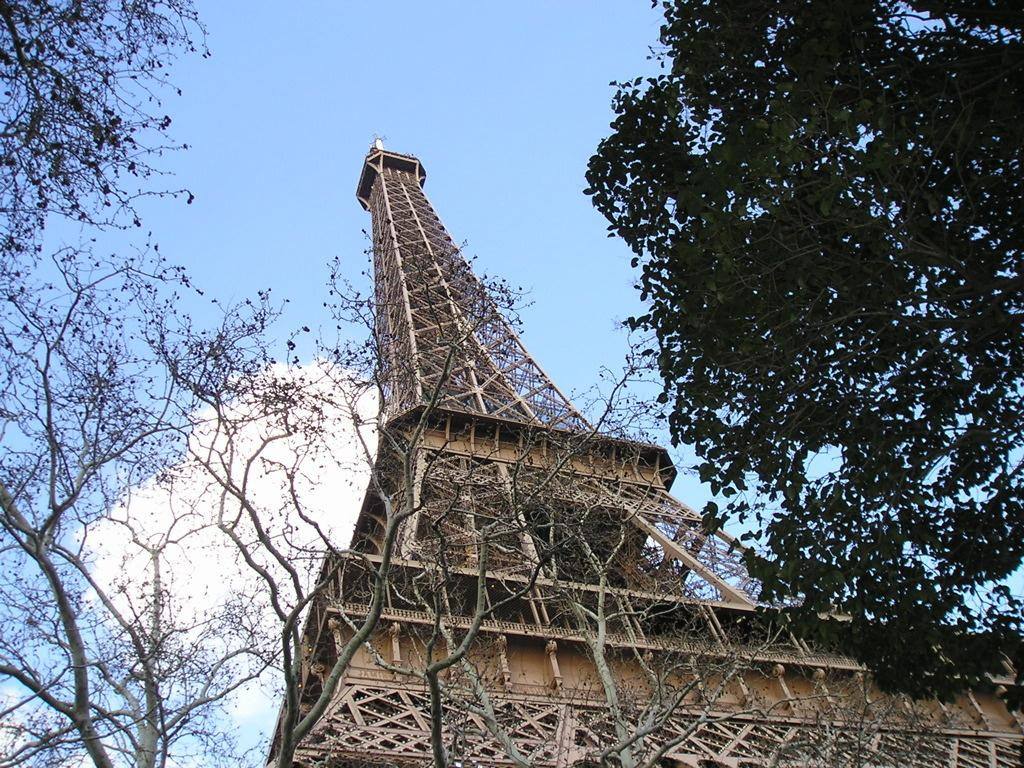What is the main structure in the image? There is a tower in the image. What can be seen in the background of the image? The background of the image includes trees. What colors are visible in the sky in the image? The sky is visible in the image, and it has blue and white colors. What type of nerve can be seen in the image? There is no nerve present in the image; it features a tower and trees in the background. 